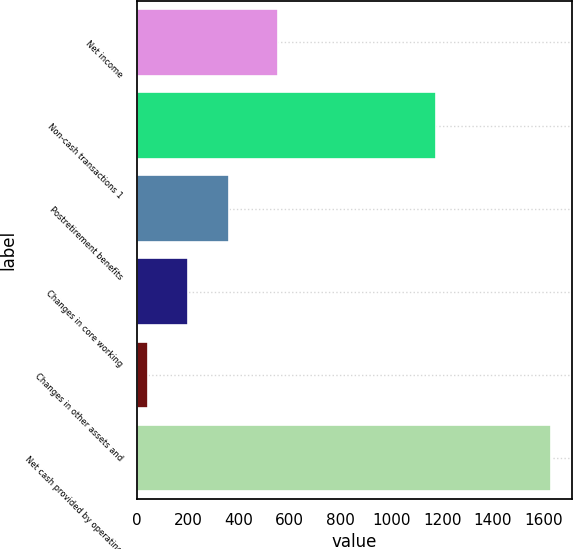<chart> <loc_0><loc_0><loc_500><loc_500><bar_chart><fcel>Net income<fcel>Non-cash transactions 1<fcel>Postretirement benefits<fcel>Changes in core working<fcel>Changes in other assets and<fcel>Net cash provided by operating<nl><fcel>553<fcel>1177<fcel>360.2<fcel>201.6<fcel>43<fcel>1629<nl></chart> 